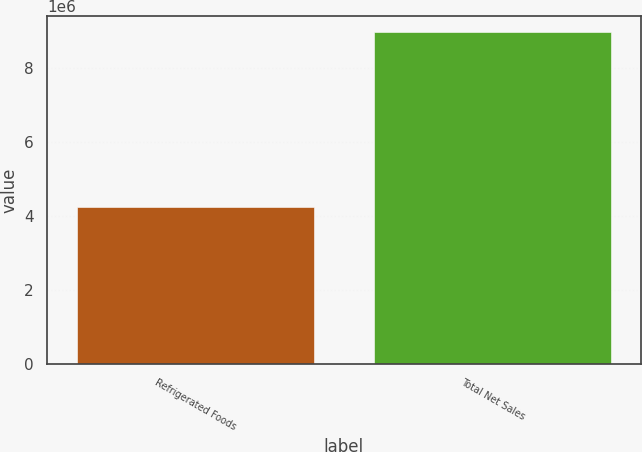Convert chart. <chart><loc_0><loc_0><loc_500><loc_500><bar_chart><fcel>Refrigerated Foods<fcel>Total Net Sales<nl><fcel>4.25905e+06<fcel>8.97054e+06<nl></chart> 